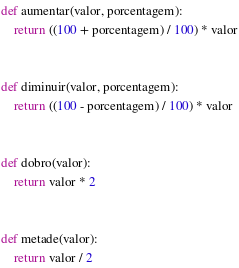Convert code to text. <code><loc_0><loc_0><loc_500><loc_500><_Python_>def aumentar(valor, porcentagem):
    return ((100 + porcentagem) / 100) * valor


def diminuir(valor, porcentagem):
    return ((100 - porcentagem) / 100) * valor


def dobro(valor):
    return valor * 2


def metade(valor):
    return valor / 2
</code> 